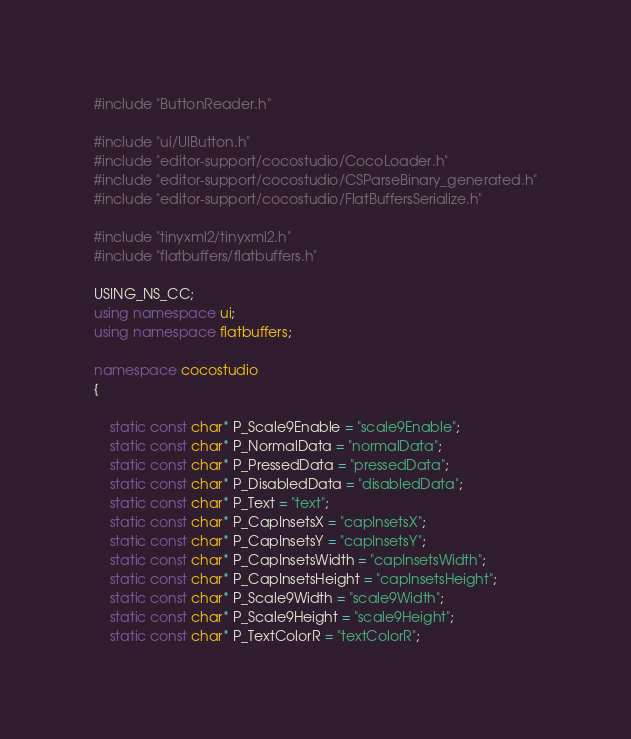<code> <loc_0><loc_0><loc_500><loc_500><_C++_>

#include "ButtonReader.h"

#include "ui/UIButton.h"
#include "editor-support/cocostudio/CocoLoader.h"
#include "editor-support/cocostudio/CSParseBinary_generated.h"
#include "editor-support/cocostudio/FlatBuffersSerialize.h"

#include "tinyxml2/tinyxml2.h"
#include "flatbuffers/flatbuffers.h"

USING_NS_CC;
using namespace ui;
using namespace flatbuffers;

namespace cocostudio
{
    
    static const char* P_Scale9Enable = "scale9Enable";
    static const char* P_NormalData = "normalData";
    static const char* P_PressedData = "pressedData";
    static const char* P_DisabledData = "disabledData";
    static const char* P_Text = "text";
    static const char* P_CapInsetsX = "capInsetsX";
    static const char* P_CapInsetsY = "capInsetsY";
    static const char* P_CapInsetsWidth = "capInsetsWidth";
    static const char* P_CapInsetsHeight = "capInsetsHeight";
    static const char* P_Scale9Width = "scale9Width";
    static const char* P_Scale9Height = "scale9Height";
    static const char* P_TextColorR = "textColorR";</code> 